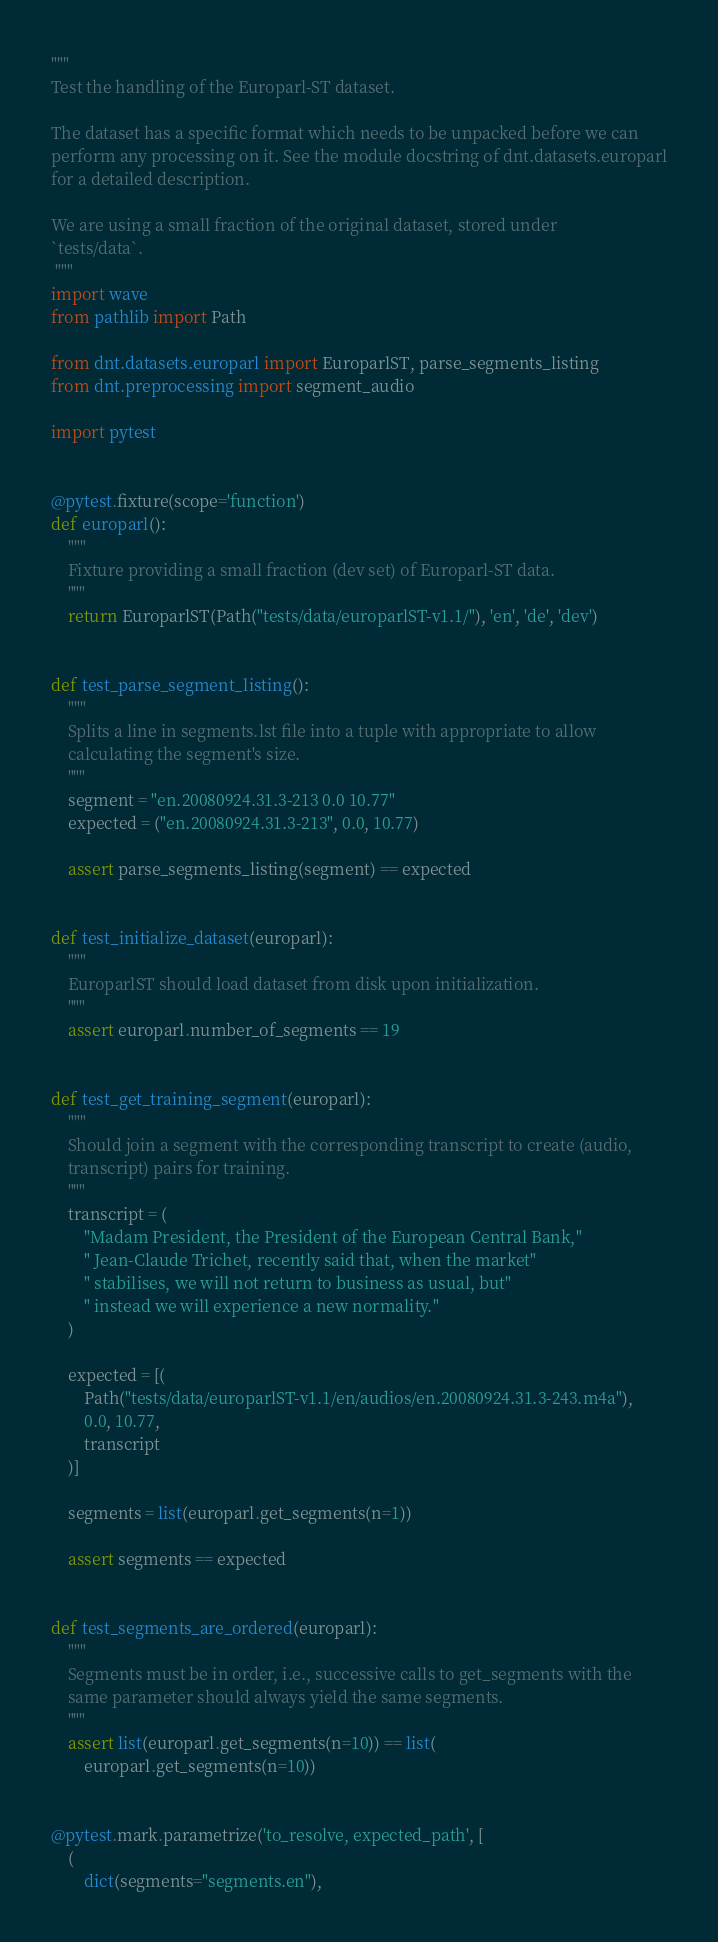Convert code to text. <code><loc_0><loc_0><loc_500><loc_500><_Python_>"""
Test the handling of the Europarl-ST dataset.

The dataset has a specific format which needs to be unpacked before we can
perform any processing on it. See the module docstring of dnt.datasets.europarl
for a detailed description.

We are using a small fraction of the original dataset, stored under
`tests/data`.
 """
import wave
from pathlib import Path

from dnt.datasets.europarl import EuroparlST, parse_segments_listing
from dnt.preprocessing import segment_audio

import pytest


@pytest.fixture(scope='function')
def europarl():
    """
    Fixture providing a small fraction (dev set) of Europarl-ST data.
    """
    return EuroparlST(Path("tests/data/europarlST-v1.1/"), 'en', 'de', 'dev')


def test_parse_segment_listing():
    """
    Splits a line in segments.lst file into a tuple with appropriate to allow
    calculating the segment's size.
    """
    segment = "en.20080924.31.3-213 0.0 10.77"
    expected = ("en.20080924.31.3-213", 0.0, 10.77)

    assert parse_segments_listing(segment) == expected


def test_initialize_dataset(europarl):
    """
    EuroparlST should load dataset from disk upon initialization.
    """
    assert europarl.number_of_segments == 19


def test_get_training_segment(europarl):
    """
    Should join a segment with the corresponding transcript to create (audio,
    transcript) pairs for training.
    """
    transcript = (
        "Madam President, the President of the European Central Bank,"
        " Jean-Claude Trichet, recently said that, when the market"
        " stabilises, we will not return to business as usual, but"
        " instead we will experience a new normality."
    )

    expected = [(
        Path("tests/data/europarlST-v1.1/en/audios/en.20080924.31.3-243.m4a"),
        0.0, 10.77,
        transcript
    )]

    segments = list(europarl.get_segments(n=1))

    assert segments == expected


def test_segments_are_ordered(europarl):
    """
    Segments must be in order, i.e., successive calls to get_segments with the
    same parameter should always yield the same segments.
    """
    assert list(europarl.get_segments(n=10)) == list(
        europarl.get_segments(n=10))


@pytest.mark.parametrize('to_resolve, expected_path', [
    (
        dict(segments="segments.en"),</code> 